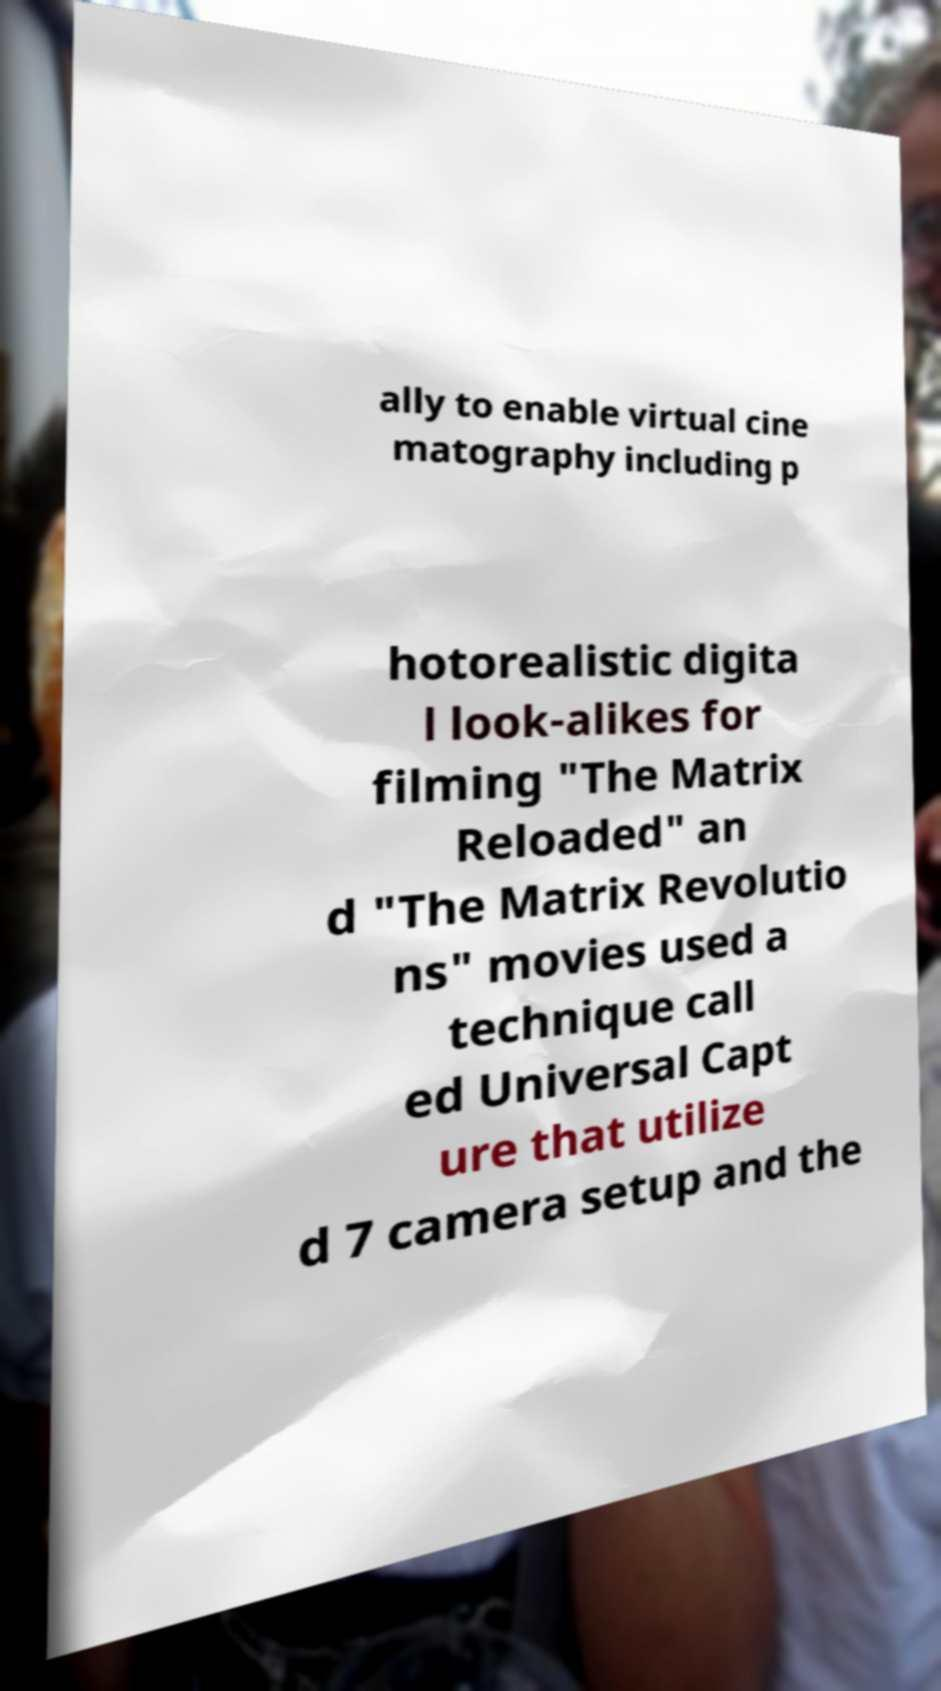Can you accurately transcribe the text from the provided image for me? ally to enable virtual cine matography including p hotorealistic digita l look-alikes for filming "The Matrix Reloaded" an d "The Matrix Revolutio ns" movies used a technique call ed Universal Capt ure that utilize d 7 camera setup and the 